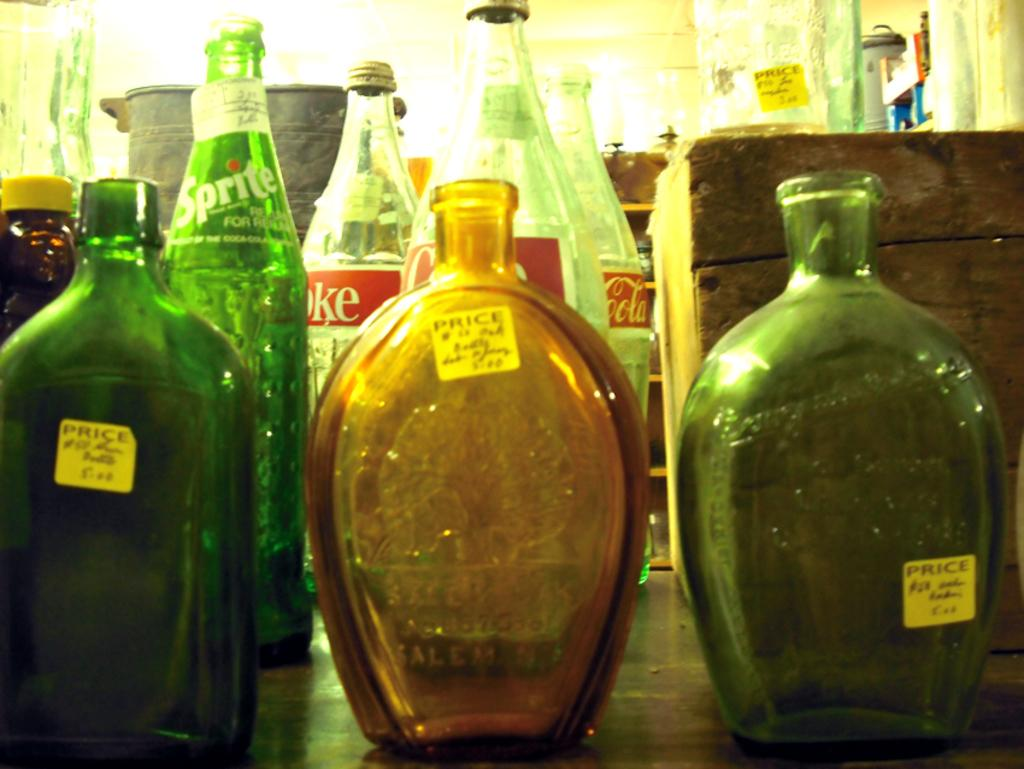<image>
Describe the image concisely. Several bottles are on a table, including Sprite and Coca Cola. 